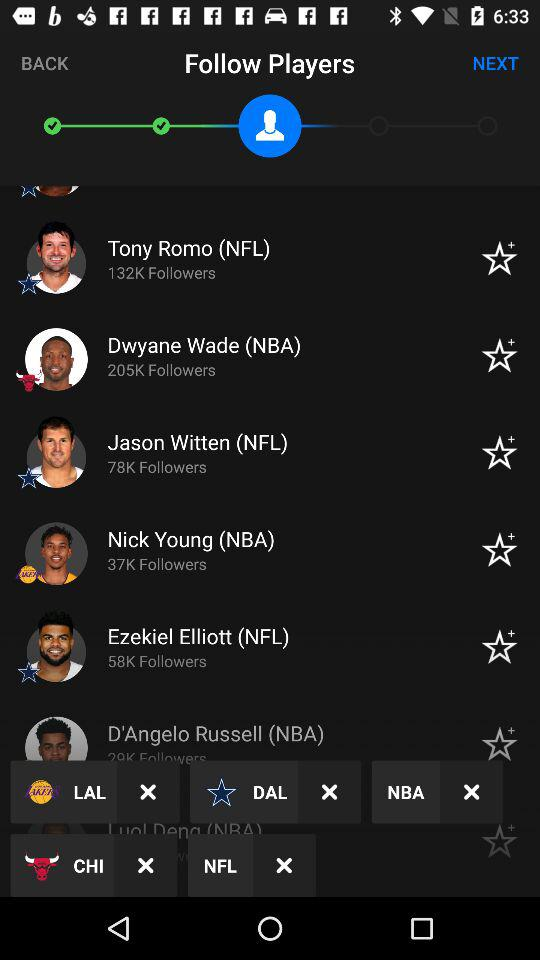How many followers does Jason Witten have? Jason Witten has 78K followers. 